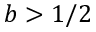<formula> <loc_0><loc_0><loc_500><loc_500>b > 1 / 2</formula> 